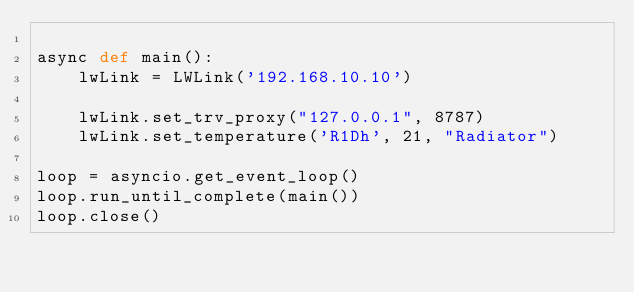<code> <loc_0><loc_0><loc_500><loc_500><_Python_>
async def main():
    lwLink = LWLink('192.168.10.10')

    lwLink.set_trv_proxy("127.0.0.1", 8787)
    lwLink.set_temperature('R1Dh', 21, "Radiator")

loop = asyncio.get_event_loop()
loop.run_until_complete(main())
loop.close()
</code> 